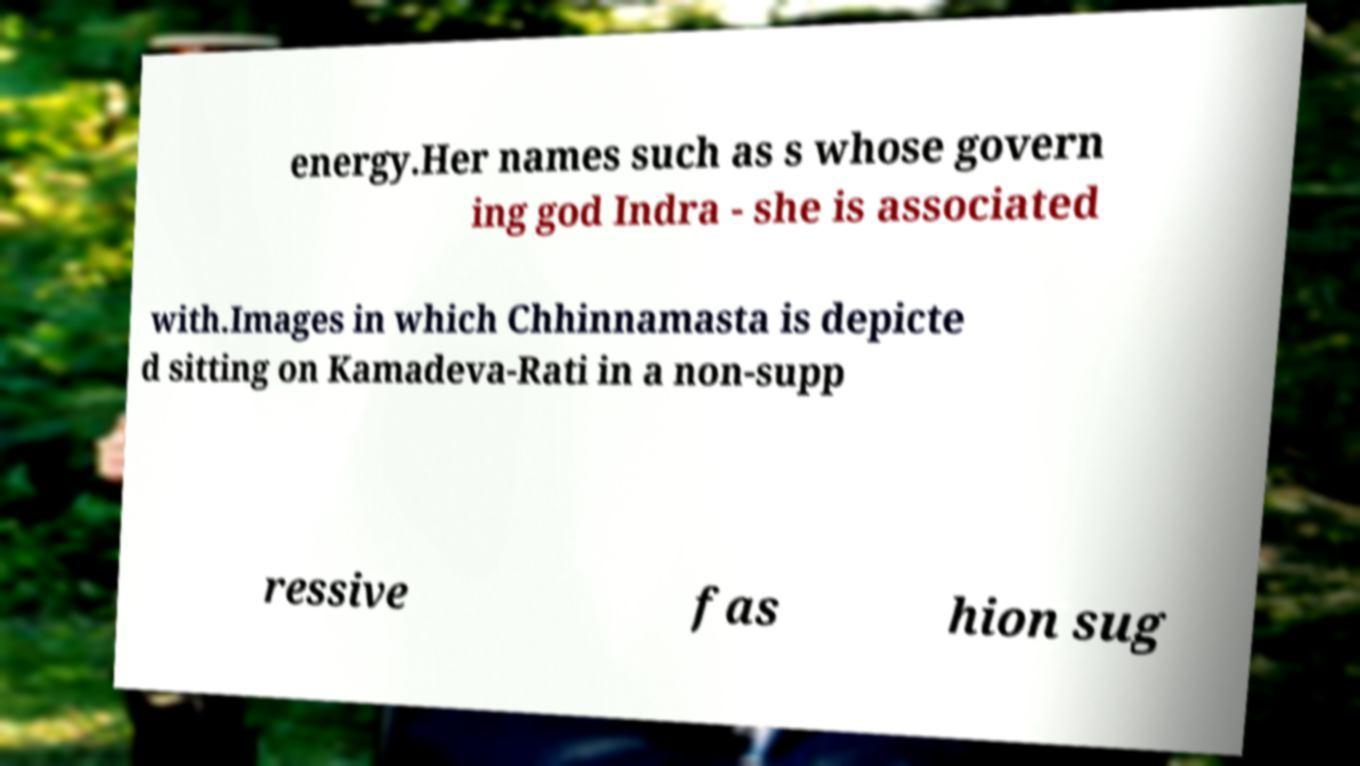For documentation purposes, I need the text within this image transcribed. Could you provide that? energy.Her names such as s whose govern ing god Indra - she is associated with.Images in which Chhinnamasta is depicte d sitting on Kamadeva-Rati in a non-supp ressive fas hion sug 